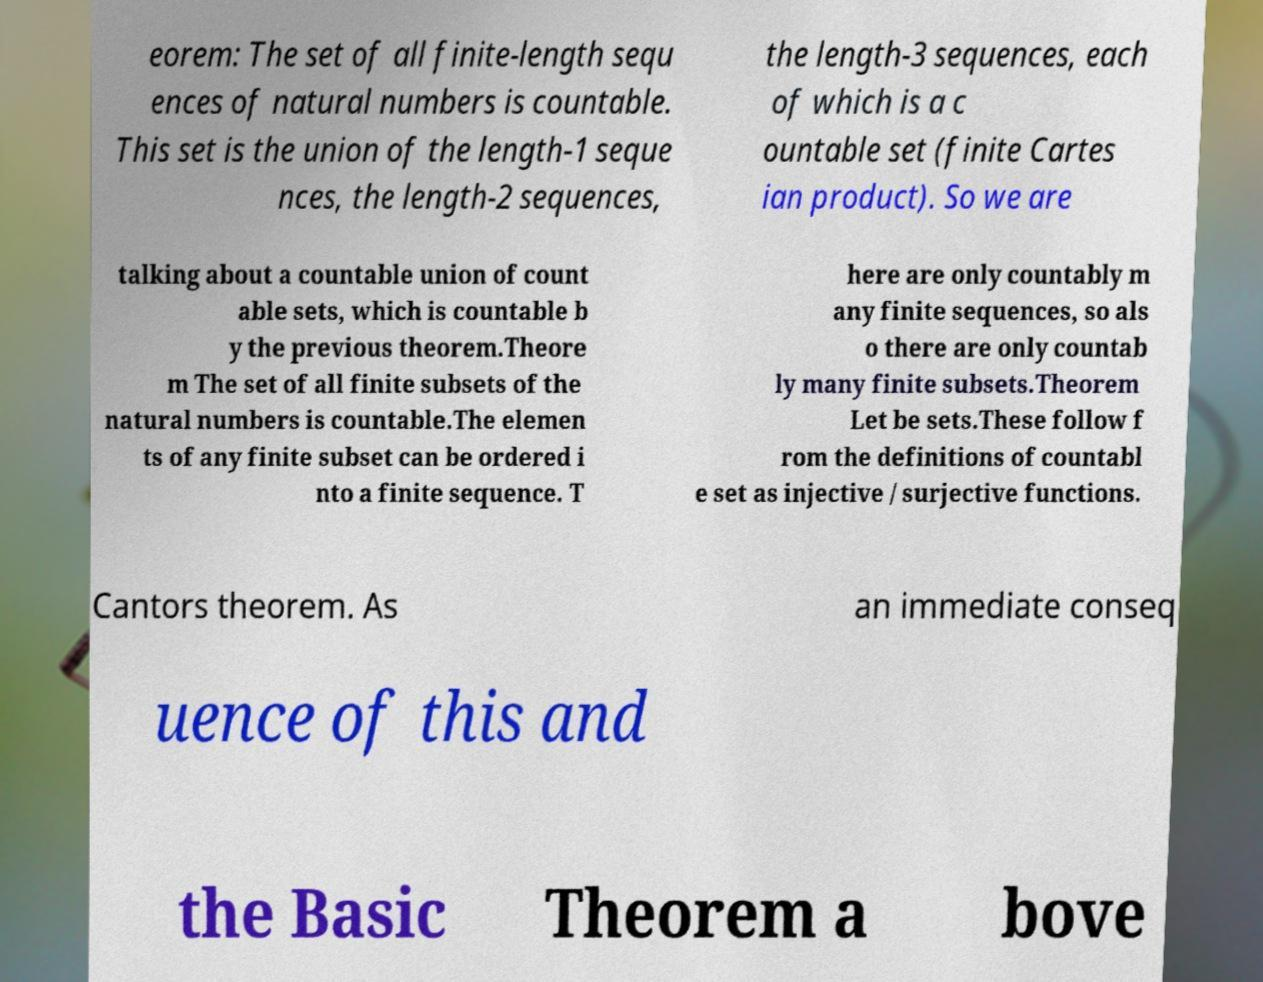Could you extract and type out the text from this image? eorem: The set of all finite-length sequ ences of natural numbers is countable. This set is the union of the length-1 seque nces, the length-2 sequences, the length-3 sequences, each of which is a c ountable set (finite Cartes ian product). So we are talking about a countable union of count able sets, which is countable b y the previous theorem.Theore m The set of all finite subsets of the natural numbers is countable.The elemen ts of any finite subset can be ordered i nto a finite sequence. T here are only countably m any finite sequences, so als o there are only countab ly many finite subsets.Theorem Let be sets.These follow f rom the definitions of countabl e set as injective / surjective functions. Cantors theorem. As an immediate conseq uence of this and the Basic Theorem a bove 